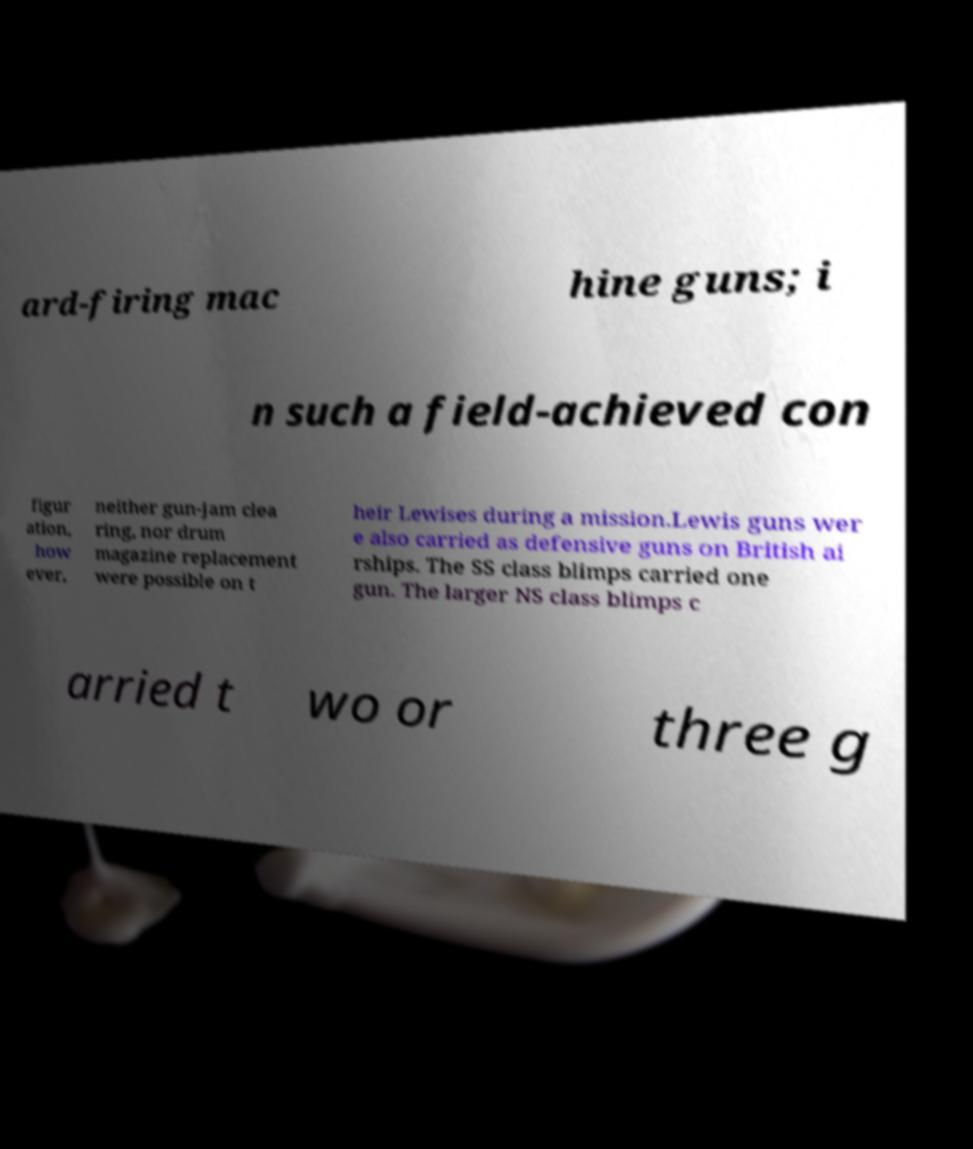What messages or text are displayed in this image? I need them in a readable, typed format. ard-firing mac hine guns; i n such a field-achieved con figur ation, how ever, neither gun-jam clea ring, nor drum magazine replacement were possible on t heir Lewises during a mission.Lewis guns wer e also carried as defensive guns on British ai rships. The SS class blimps carried one gun. The larger NS class blimps c arried t wo or three g 